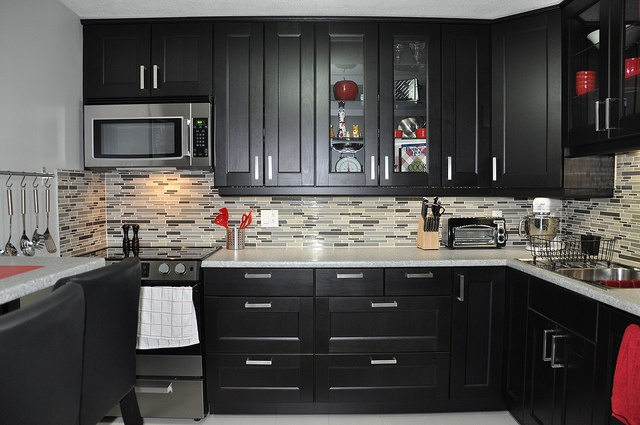Describe the objects in this image and their specific colors. I can see chair in gray, black, and purple tones, microwave in gray and black tones, chair in gray and black tones, oven in gray and black tones, and dining table in gray, darkgray, brown, and black tones in this image. 